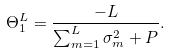<formula> <loc_0><loc_0><loc_500><loc_500>\Theta _ { 1 } ^ { L } = \frac { - L } { \sum _ { m = 1 } ^ { L } \sigma _ { m } ^ { 2 } + P } .</formula> 